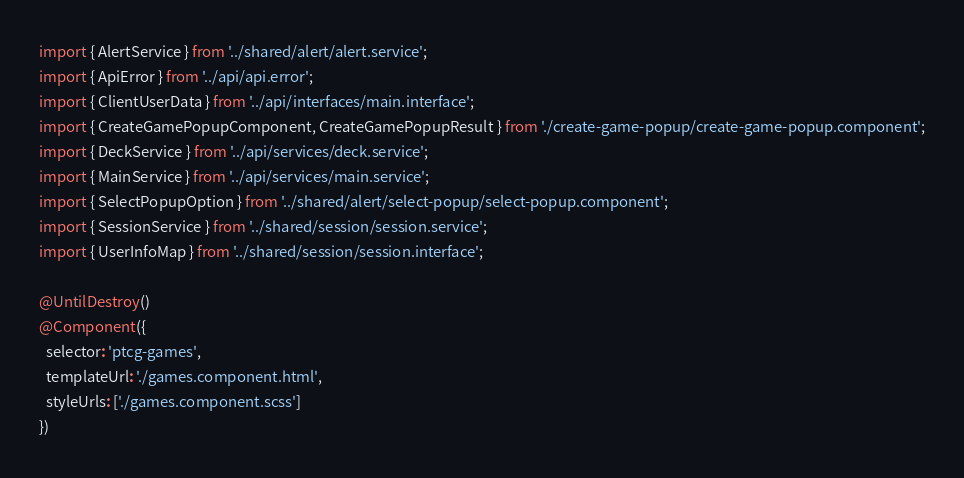<code> <loc_0><loc_0><loc_500><loc_500><_TypeScript_>import { AlertService } from '../shared/alert/alert.service';
import { ApiError } from '../api/api.error';
import { ClientUserData } from '../api/interfaces/main.interface';
import { CreateGamePopupComponent, CreateGamePopupResult } from './create-game-popup/create-game-popup.component';
import { DeckService } from '../api/services/deck.service';
import { MainService } from '../api/services/main.service';
import { SelectPopupOption } from '../shared/alert/select-popup/select-popup.component';
import { SessionService } from '../shared/session/session.service';
import { UserInfoMap } from '../shared/session/session.interface';

@UntilDestroy()
@Component({
  selector: 'ptcg-games',
  templateUrl: './games.component.html',
  styleUrls: ['./games.component.scss']
})</code> 